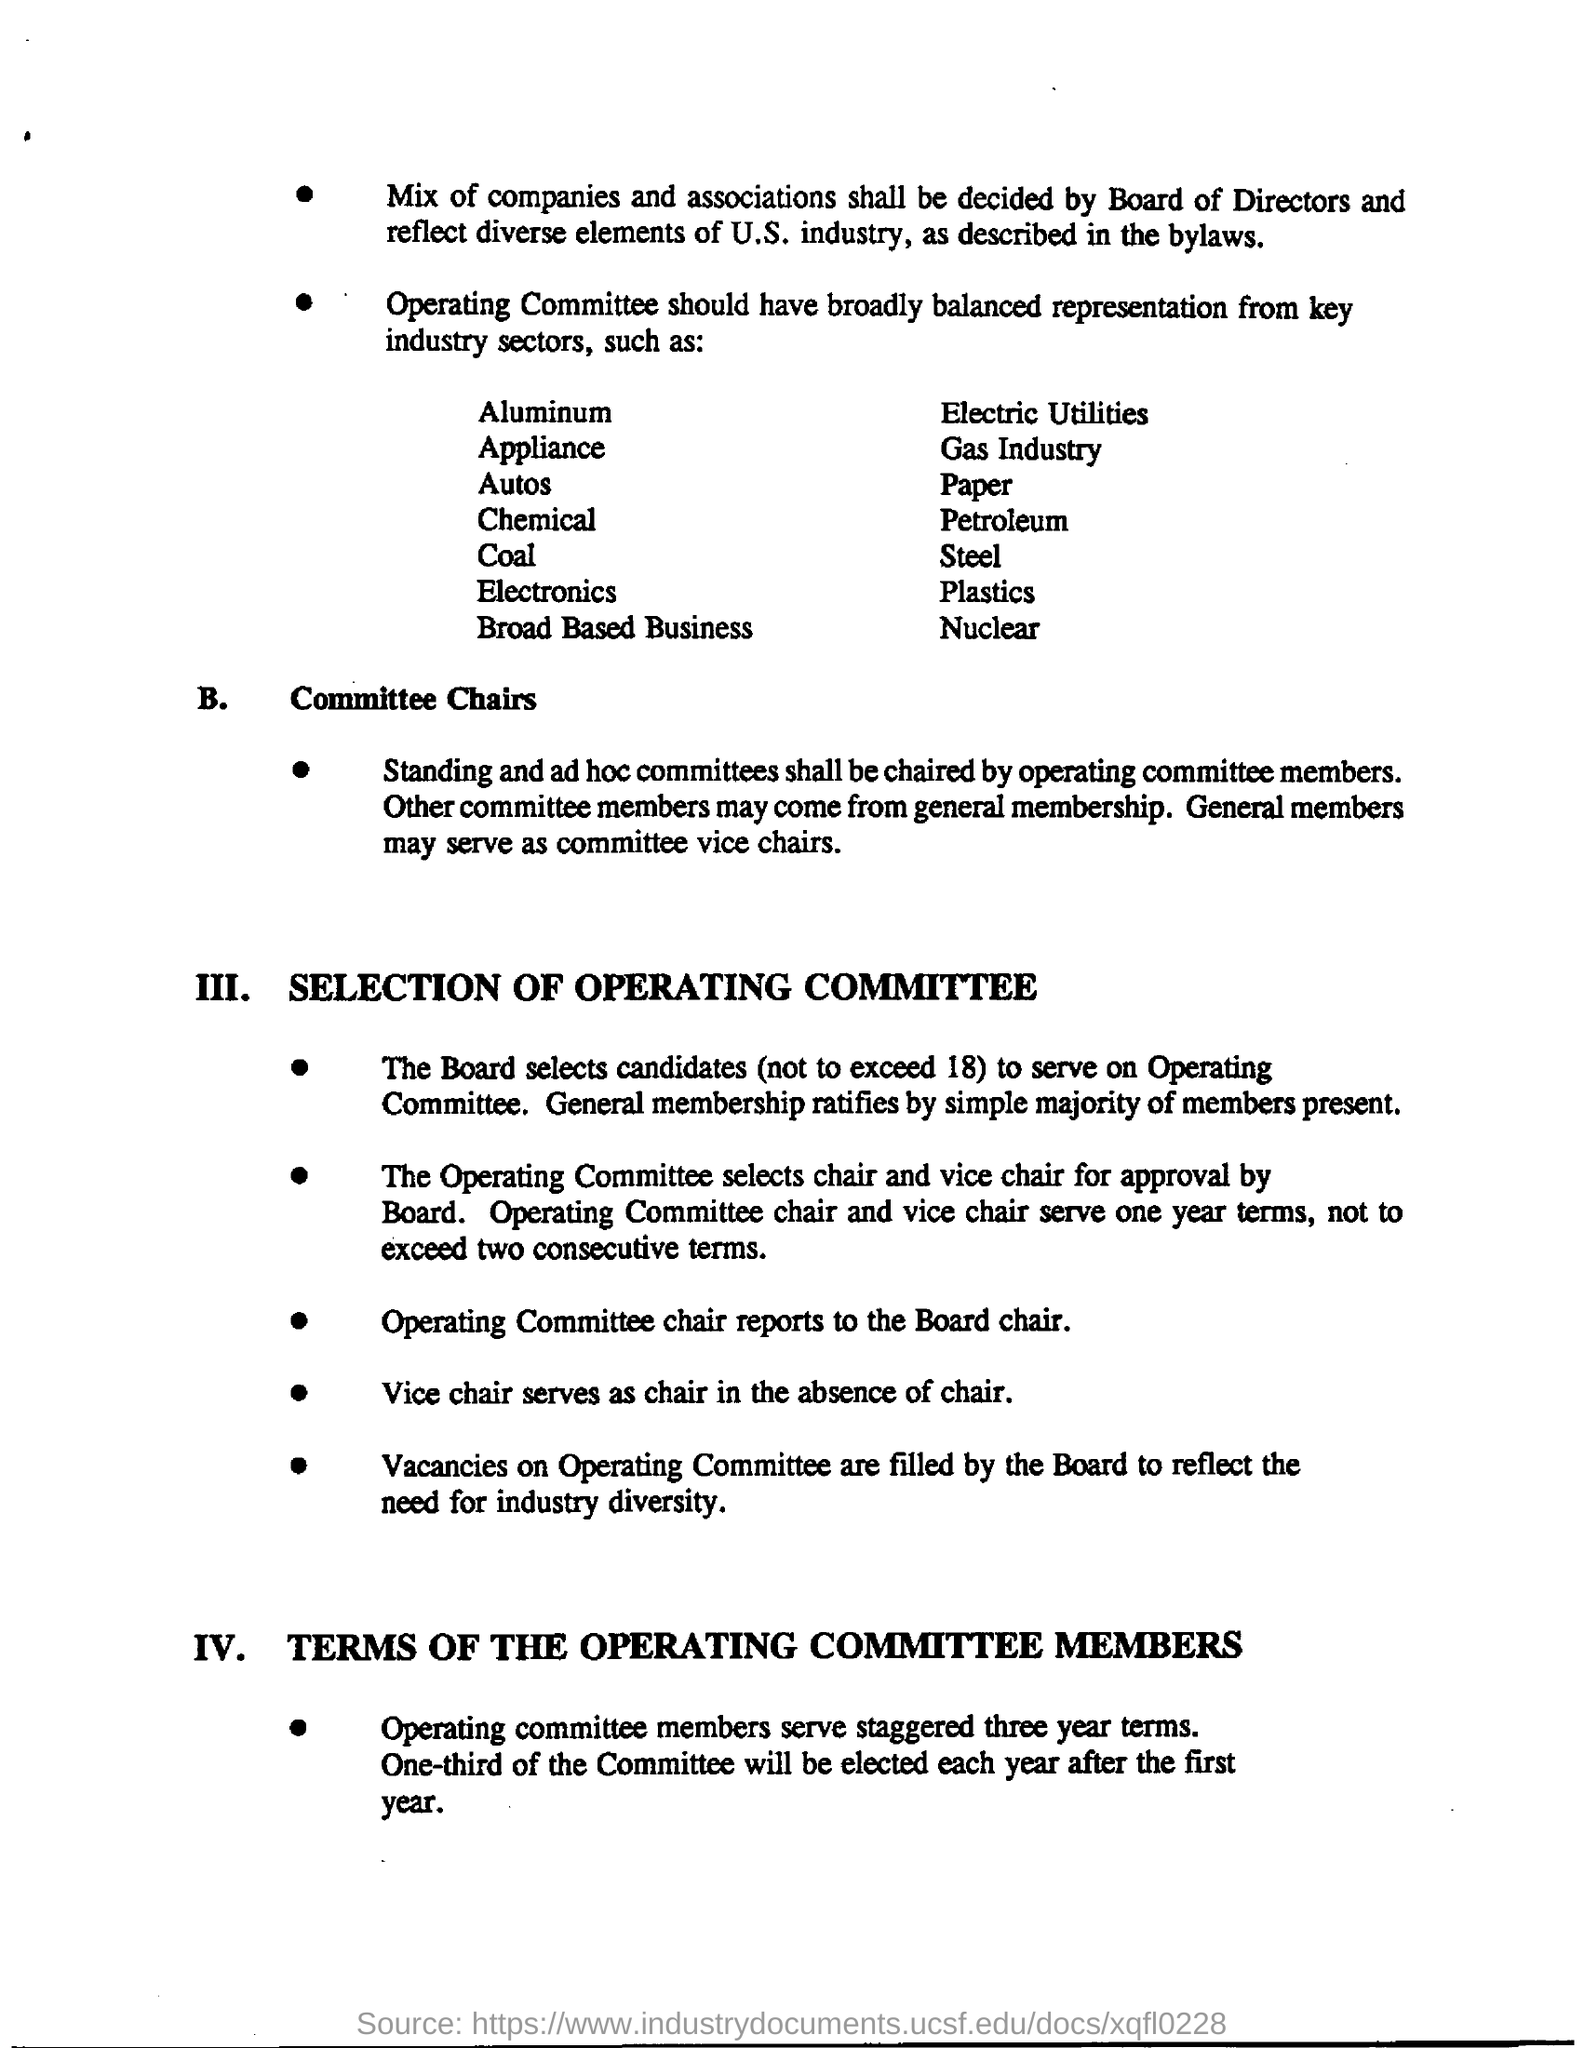To whom does Operating Committee report?
Provide a short and direct response. The board chair. 